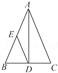What can you say about the angles formed by the altitude AD and the sides of triangle ABC? The altitude AD from vertex A to side BC creates two right angles at point D, one with side AB and one with side AC. Since these two angles are right angles, they each measure 90 degrees, demonstrating that AD is perpendicular to BC. 